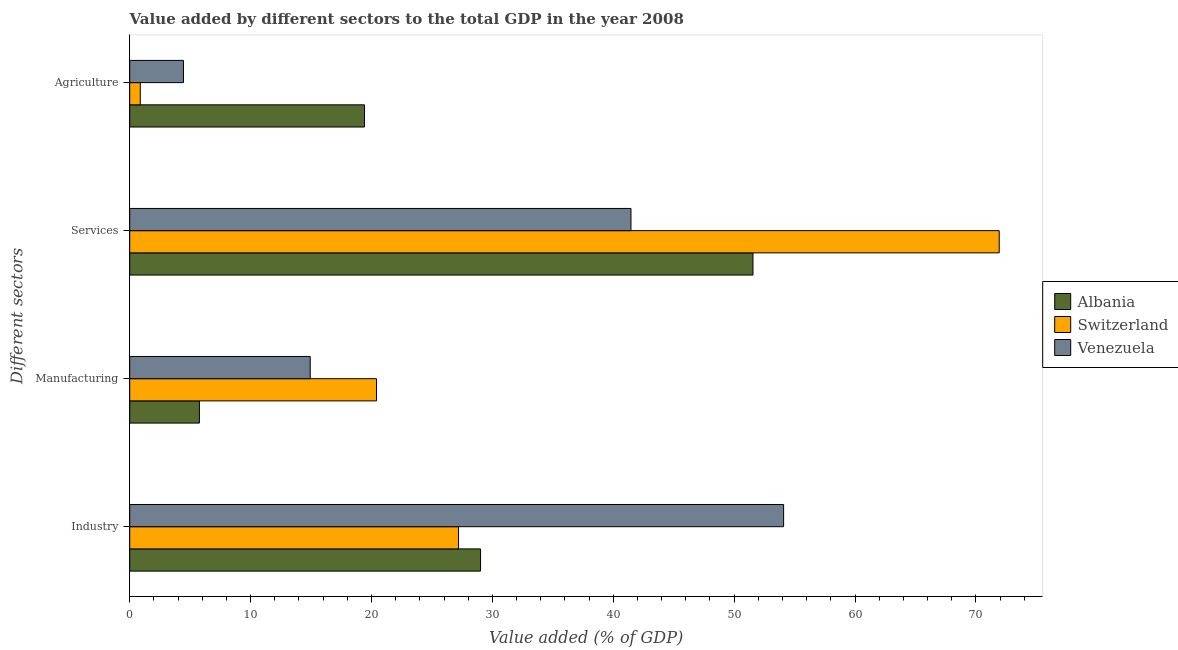How many different coloured bars are there?
Your response must be concise. 3. Are the number of bars on each tick of the Y-axis equal?
Provide a succinct answer. Yes. How many bars are there on the 4th tick from the bottom?
Your answer should be very brief. 3. What is the label of the 2nd group of bars from the top?
Provide a succinct answer. Services. What is the value added by industrial sector in Switzerland?
Keep it short and to the point. 27.2. Across all countries, what is the maximum value added by manufacturing sector?
Give a very brief answer. 20.41. Across all countries, what is the minimum value added by services sector?
Ensure brevity in your answer.  41.46. In which country was the value added by industrial sector maximum?
Give a very brief answer. Venezuela. In which country was the value added by services sector minimum?
Provide a short and direct response. Venezuela. What is the total value added by agricultural sector in the graph?
Offer a very short reply. 24.74. What is the difference between the value added by agricultural sector in Venezuela and that in Switzerland?
Offer a very short reply. 3.57. What is the difference between the value added by industrial sector in Venezuela and the value added by manufacturing sector in Switzerland?
Your answer should be very brief. 33.68. What is the average value added by services sector per country?
Offer a terse response. 54.98. What is the difference between the value added by industrial sector and value added by services sector in Switzerland?
Make the answer very short. -44.73. In how many countries, is the value added by industrial sector greater than 30 %?
Provide a short and direct response. 1. What is the ratio of the value added by services sector in Switzerland to that in Albania?
Provide a short and direct response. 1.4. What is the difference between the highest and the second highest value added by industrial sector?
Your answer should be very brief. 25.07. What is the difference between the highest and the lowest value added by industrial sector?
Your response must be concise. 26.89. In how many countries, is the value added by manufacturing sector greater than the average value added by manufacturing sector taken over all countries?
Provide a succinct answer. 2. Is the sum of the value added by industrial sector in Venezuela and Switzerland greater than the maximum value added by manufacturing sector across all countries?
Offer a very short reply. Yes. Is it the case that in every country, the sum of the value added by agricultural sector and value added by manufacturing sector is greater than the sum of value added by industrial sector and value added by services sector?
Make the answer very short. No. What does the 2nd bar from the top in Manufacturing represents?
Offer a terse response. Switzerland. What does the 2nd bar from the bottom in Manufacturing represents?
Offer a very short reply. Switzerland. Is it the case that in every country, the sum of the value added by industrial sector and value added by manufacturing sector is greater than the value added by services sector?
Provide a succinct answer. No. How many bars are there?
Offer a very short reply. 12. How many countries are there in the graph?
Provide a succinct answer. 3. Does the graph contain grids?
Offer a terse response. No. What is the title of the graph?
Give a very brief answer. Value added by different sectors to the total GDP in the year 2008. What is the label or title of the X-axis?
Provide a short and direct response. Value added (% of GDP). What is the label or title of the Y-axis?
Provide a short and direct response. Different sectors. What is the Value added (% of GDP) in Albania in Industry?
Give a very brief answer. 29.02. What is the Value added (% of GDP) of Switzerland in Industry?
Ensure brevity in your answer.  27.2. What is the Value added (% of GDP) in Venezuela in Industry?
Keep it short and to the point. 54.09. What is the Value added (% of GDP) in Albania in Manufacturing?
Your answer should be very brief. 5.76. What is the Value added (% of GDP) of Switzerland in Manufacturing?
Provide a succinct answer. 20.41. What is the Value added (% of GDP) of Venezuela in Manufacturing?
Keep it short and to the point. 14.93. What is the Value added (% of GDP) in Albania in Services?
Make the answer very short. 51.56. What is the Value added (% of GDP) of Switzerland in Services?
Provide a succinct answer. 71.93. What is the Value added (% of GDP) of Venezuela in Services?
Your answer should be compact. 41.46. What is the Value added (% of GDP) in Albania in Agriculture?
Keep it short and to the point. 19.42. What is the Value added (% of GDP) of Switzerland in Agriculture?
Make the answer very short. 0.87. What is the Value added (% of GDP) in Venezuela in Agriculture?
Your response must be concise. 4.44. Across all Different sectors, what is the maximum Value added (% of GDP) in Albania?
Keep it short and to the point. 51.56. Across all Different sectors, what is the maximum Value added (% of GDP) of Switzerland?
Your answer should be compact. 71.93. Across all Different sectors, what is the maximum Value added (% of GDP) of Venezuela?
Provide a succinct answer. 54.09. Across all Different sectors, what is the minimum Value added (% of GDP) of Albania?
Your answer should be compact. 5.76. Across all Different sectors, what is the minimum Value added (% of GDP) in Switzerland?
Your response must be concise. 0.87. Across all Different sectors, what is the minimum Value added (% of GDP) of Venezuela?
Offer a very short reply. 4.44. What is the total Value added (% of GDP) in Albania in the graph?
Offer a terse response. 105.76. What is the total Value added (% of GDP) in Switzerland in the graph?
Provide a succinct answer. 120.41. What is the total Value added (% of GDP) in Venezuela in the graph?
Make the answer very short. 114.93. What is the difference between the Value added (% of GDP) of Albania in Industry and that in Manufacturing?
Provide a succinct answer. 23.26. What is the difference between the Value added (% of GDP) in Switzerland in Industry and that in Manufacturing?
Ensure brevity in your answer.  6.79. What is the difference between the Value added (% of GDP) in Venezuela in Industry and that in Manufacturing?
Your answer should be compact. 39.16. What is the difference between the Value added (% of GDP) of Albania in Industry and that in Services?
Offer a very short reply. -22.54. What is the difference between the Value added (% of GDP) of Switzerland in Industry and that in Services?
Provide a succinct answer. -44.73. What is the difference between the Value added (% of GDP) in Venezuela in Industry and that in Services?
Provide a succinct answer. 12.63. What is the difference between the Value added (% of GDP) in Albania in Industry and that in Agriculture?
Your answer should be very brief. 9.6. What is the difference between the Value added (% of GDP) of Switzerland in Industry and that in Agriculture?
Offer a terse response. 26.33. What is the difference between the Value added (% of GDP) of Venezuela in Industry and that in Agriculture?
Keep it short and to the point. 49.65. What is the difference between the Value added (% of GDP) in Albania in Manufacturing and that in Services?
Your response must be concise. -45.79. What is the difference between the Value added (% of GDP) in Switzerland in Manufacturing and that in Services?
Your answer should be compact. -51.51. What is the difference between the Value added (% of GDP) in Venezuela in Manufacturing and that in Services?
Offer a terse response. -26.53. What is the difference between the Value added (% of GDP) in Albania in Manufacturing and that in Agriculture?
Your answer should be very brief. -13.66. What is the difference between the Value added (% of GDP) of Switzerland in Manufacturing and that in Agriculture?
Your response must be concise. 19.54. What is the difference between the Value added (% of GDP) in Venezuela in Manufacturing and that in Agriculture?
Give a very brief answer. 10.49. What is the difference between the Value added (% of GDP) in Albania in Services and that in Agriculture?
Give a very brief answer. 32.14. What is the difference between the Value added (% of GDP) of Switzerland in Services and that in Agriculture?
Your answer should be compact. 71.05. What is the difference between the Value added (% of GDP) in Venezuela in Services and that in Agriculture?
Offer a terse response. 37.02. What is the difference between the Value added (% of GDP) in Albania in Industry and the Value added (% of GDP) in Switzerland in Manufacturing?
Your answer should be very brief. 8.61. What is the difference between the Value added (% of GDP) of Albania in Industry and the Value added (% of GDP) of Venezuela in Manufacturing?
Make the answer very short. 14.09. What is the difference between the Value added (% of GDP) in Switzerland in Industry and the Value added (% of GDP) in Venezuela in Manufacturing?
Your answer should be compact. 12.27. What is the difference between the Value added (% of GDP) in Albania in Industry and the Value added (% of GDP) in Switzerland in Services?
Offer a terse response. -42.9. What is the difference between the Value added (% of GDP) in Albania in Industry and the Value added (% of GDP) in Venezuela in Services?
Your response must be concise. -12.44. What is the difference between the Value added (% of GDP) in Switzerland in Industry and the Value added (% of GDP) in Venezuela in Services?
Keep it short and to the point. -14.26. What is the difference between the Value added (% of GDP) in Albania in Industry and the Value added (% of GDP) in Switzerland in Agriculture?
Offer a terse response. 28.15. What is the difference between the Value added (% of GDP) in Albania in Industry and the Value added (% of GDP) in Venezuela in Agriculture?
Offer a terse response. 24.58. What is the difference between the Value added (% of GDP) of Switzerland in Industry and the Value added (% of GDP) of Venezuela in Agriculture?
Your answer should be compact. 22.76. What is the difference between the Value added (% of GDP) in Albania in Manufacturing and the Value added (% of GDP) in Switzerland in Services?
Give a very brief answer. -66.16. What is the difference between the Value added (% of GDP) of Albania in Manufacturing and the Value added (% of GDP) of Venezuela in Services?
Your response must be concise. -35.7. What is the difference between the Value added (% of GDP) of Switzerland in Manufacturing and the Value added (% of GDP) of Venezuela in Services?
Keep it short and to the point. -21.05. What is the difference between the Value added (% of GDP) in Albania in Manufacturing and the Value added (% of GDP) in Switzerland in Agriculture?
Make the answer very short. 4.89. What is the difference between the Value added (% of GDP) of Albania in Manufacturing and the Value added (% of GDP) of Venezuela in Agriculture?
Offer a very short reply. 1.32. What is the difference between the Value added (% of GDP) of Switzerland in Manufacturing and the Value added (% of GDP) of Venezuela in Agriculture?
Provide a succinct answer. 15.97. What is the difference between the Value added (% of GDP) of Albania in Services and the Value added (% of GDP) of Switzerland in Agriculture?
Provide a short and direct response. 50.68. What is the difference between the Value added (% of GDP) in Albania in Services and the Value added (% of GDP) in Venezuela in Agriculture?
Ensure brevity in your answer.  47.11. What is the difference between the Value added (% of GDP) of Switzerland in Services and the Value added (% of GDP) of Venezuela in Agriculture?
Offer a very short reply. 67.48. What is the average Value added (% of GDP) of Albania per Different sectors?
Offer a terse response. 26.44. What is the average Value added (% of GDP) in Switzerland per Different sectors?
Provide a short and direct response. 30.1. What is the average Value added (% of GDP) of Venezuela per Different sectors?
Give a very brief answer. 28.73. What is the difference between the Value added (% of GDP) of Albania and Value added (% of GDP) of Switzerland in Industry?
Make the answer very short. 1.82. What is the difference between the Value added (% of GDP) in Albania and Value added (% of GDP) in Venezuela in Industry?
Offer a terse response. -25.07. What is the difference between the Value added (% of GDP) of Switzerland and Value added (% of GDP) of Venezuela in Industry?
Offer a terse response. -26.89. What is the difference between the Value added (% of GDP) in Albania and Value added (% of GDP) in Switzerland in Manufacturing?
Provide a short and direct response. -14.65. What is the difference between the Value added (% of GDP) of Albania and Value added (% of GDP) of Venezuela in Manufacturing?
Keep it short and to the point. -9.17. What is the difference between the Value added (% of GDP) of Switzerland and Value added (% of GDP) of Venezuela in Manufacturing?
Make the answer very short. 5.48. What is the difference between the Value added (% of GDP) in Albania and Value added (% of GDP) in Switzerland in Services?
Your answer should be very brief. -20.37. What is the difference between the Value added (% of GDP) in Albania and Value added (% of GDP) in Venezuela in Services?
Ensure brevity in your answer.  10.09. What is the difference between the Value added (% of GDP) in Switzerland and Value added (% of GDP) in Venezuela in Services?
Your answer should be compact. 30.46. What is the difference between the Value added (% of GDP) in Albania and Value added (% of GDP) in Switzerland in Agriculture?
Your answer should be compact. 18.55. What is the difference between the Value added (% of GDP) of Albania and Value added (% of GDP) of Venezuela in Agriculture?
Keep it short and to the point. 14.98. What is the difference between the Value added (% of GDP) of Switzerland and Value added (% of GDP) of Venezuela in Agriculture?
Give a very brief answer. -3.57. What is the ratio of the Value added (% of GDP) of Albania in Industry to that in Manufacturing?
Offer a very short reply. 5.03. What is the ratio of the Value added (% of GDP) in Switzerland in Industry to that in Manufacturing?
Give a very brief answer. 1.33. What is the ratio of the Value added (% of GDP) in Venezuela in Industry to that in Manufacturing?
Make the answer very short. 3.62. What is the ratio of the Value added (% of GDP) of Albania in Industry to that in Services?
Your answer should be compact. 0.56. What is the ratio of the Value added (% of GDP) in Switzerland in Industry to that in Services?
Your answer should be very brief. 0.38. What is the ratio of the Value added (% of GDP) in Venezuela in Industry to that in Services?
Keep it short and to the point. 1.3. What is the ratio of the Value added (% of GDP) in Albania in Industry to that in Agriculture?
Your answer should be compact. 1.49. What is the ratio of the Value added (% of GDP) of Switzerland in Industry to that in Agriculture?
Make the answer very short. 31.15. What is the ratio of the Value added (% of GDP) in Venezuela in Industry to that in Agriculture?
Offer a terse response. 12.17. What is the ratio of the Value added (% of GDP) in Albania in Manufacturing to that in Services?
Give a very brief answer. 0.11. What is the ratio of the Value added (% of GDP) in Switzerland in Manufacturing to that in Services?
Keep it short and to the point. 0.28. What is the ratio of the Value added (% of GDP) in Venezuela in Manufacturing to that in Services?
Keep it short and to the point. 0.36. What is the ratio of the Value added (% of GDP) in Albania in Manufacturing to that in Agriculture?
Offer a terse response. 0.3. What is the ratio of the Value added (% of GDP) in Switzerland in Manufacturing to that in Agriculture?
Offer a terse response. 23.38. What is the ratio of the Value added (% of GDP) in Venezuela in Manufacturing to that in Agriculture?
Make the answer very short. 3.36. What is the ratio of the Value added (% of GDP) of Albania in Services to that in Agriculture?
Your answer should be very brief. 2.65. What is the ratio of the Value added (% of GDP) of Switzerland in Services to that in Agriculture?
Offer a very short reply. 82.37. What is the ratio of the Value added (% of GDP) in Venezuela in Services to that in Agriculture?
Ensure brevity in your answer.  9.33. What is the difference between the highest and the second highest Value added (% of GDP) of Albania?
Provide a succinct answer. 22.54. What is the difference between the highest and the second highest Value added (% of GDP) in Switzerland?
Provide a succinct answer. 44.73. What is the difference between the highest and the second highest Value added (% of GDP) of Venezuela?
Make the answer very short. 12.63. What is the difference between the highest and the lowest Value added (% of GDP) of Albania?
Your answer should be compact. 45.79. What is the difference between the highest and the lowest Value added (% of GDP) in Switzerland?
Keep it short and to the point. 71.05. What is the difference between the highest and the lowest Value added (% of GDP) in Venezuela?
Your answer should be compact. 49.65. 